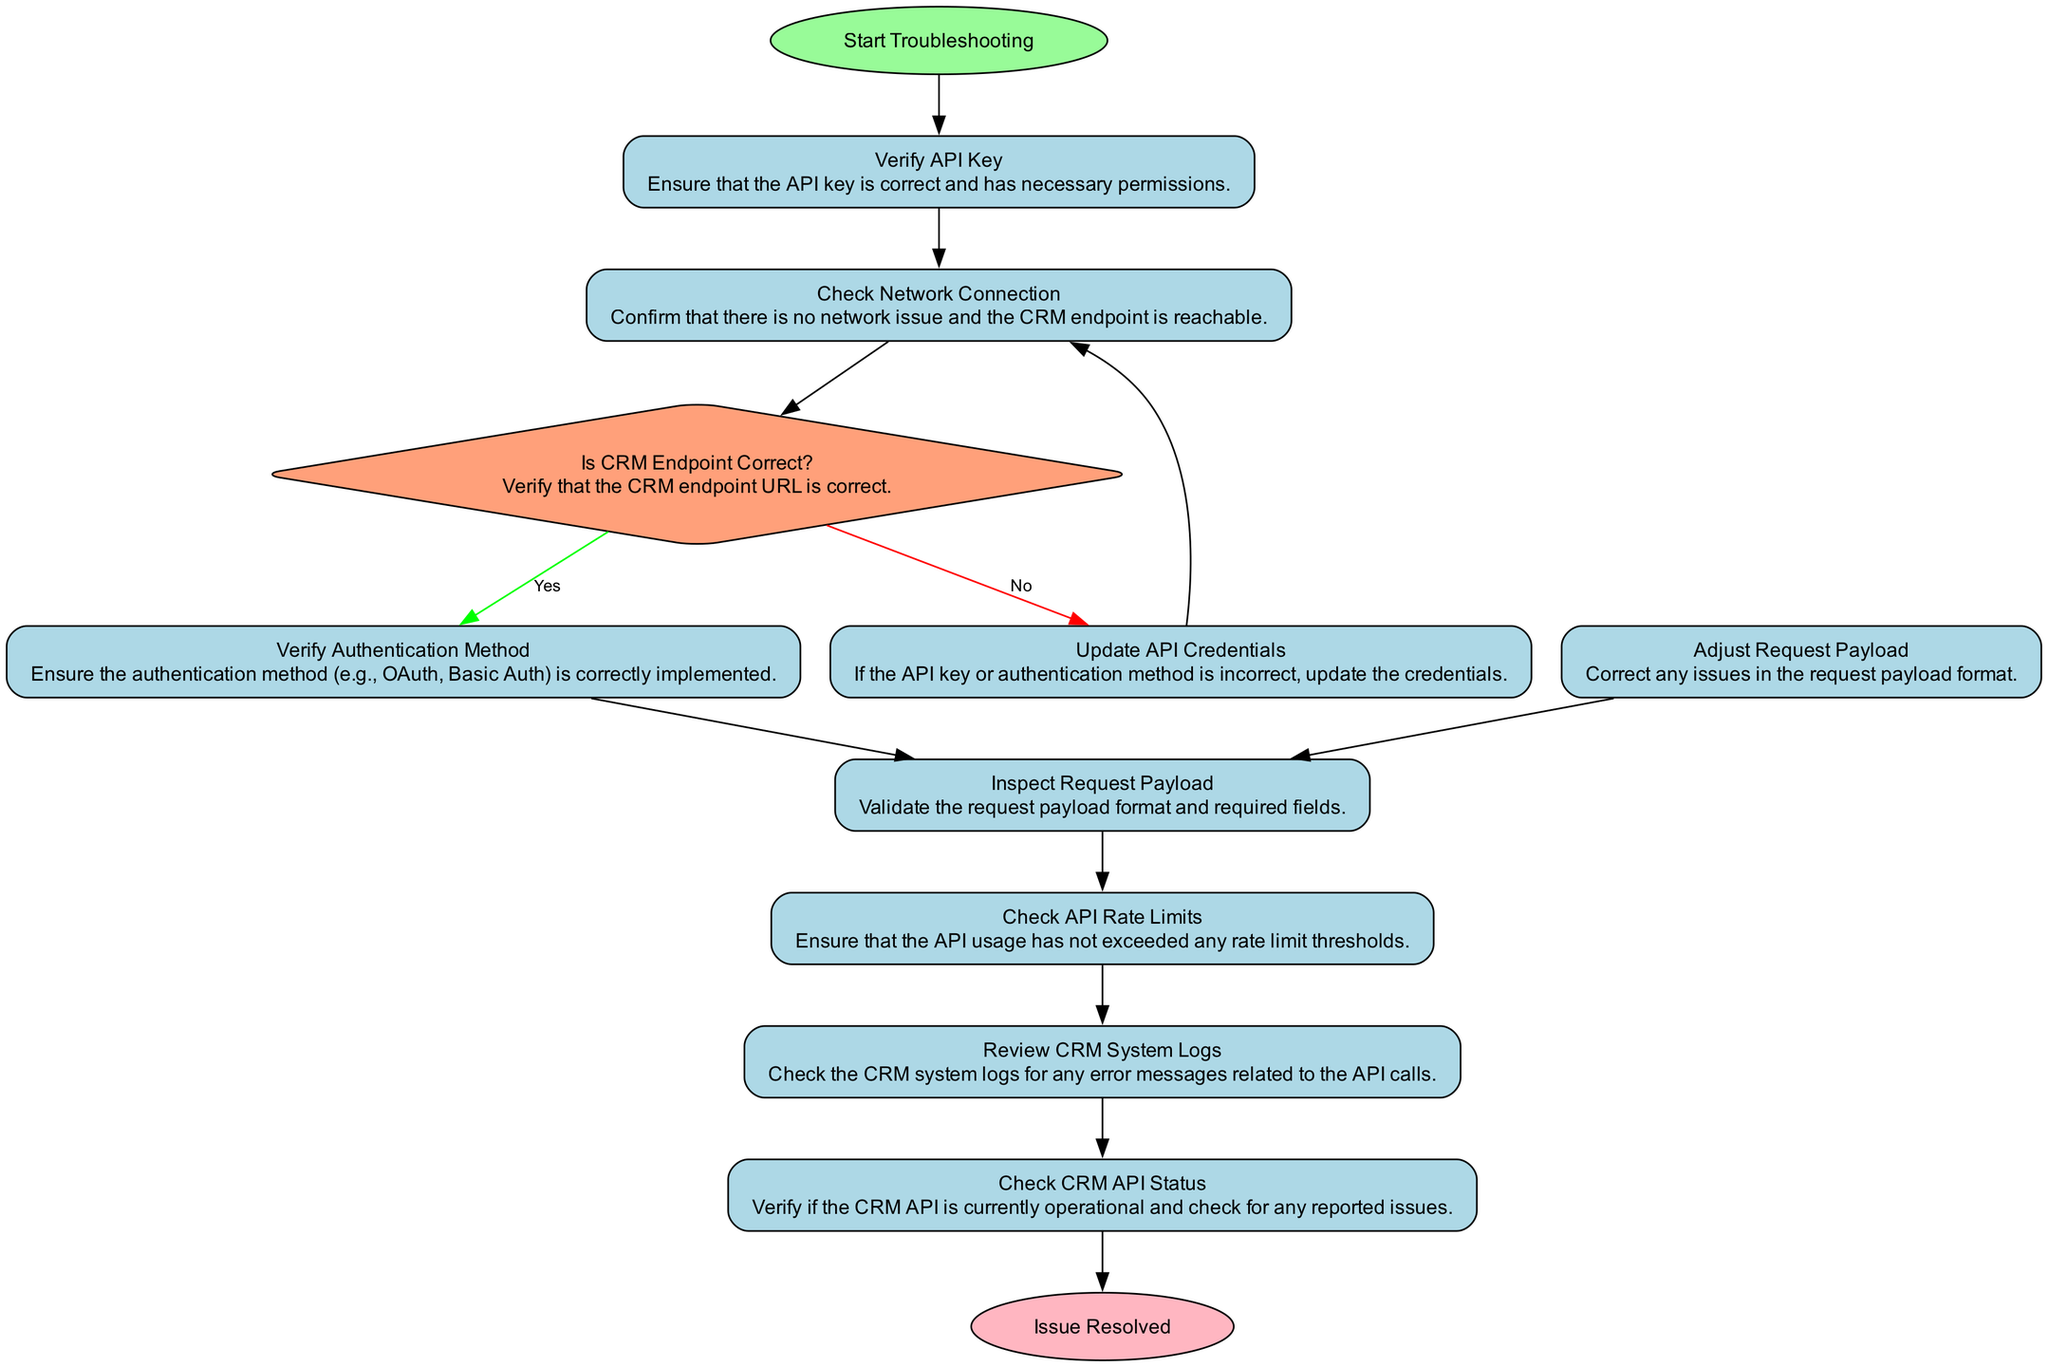What is the first step in the troubleshooting process? The first step is labeled as "Start Troubleshooting," which serves as the entry point to the flow chart.
Answer: Start Troubleshooting How many processes are present in the diagram? By counting the nodes with the type "process," I find that there are seven process nodes in the diagram (check_api_key, check_network, check_authentication, inspect_payload, check_rate_limit, review_logs, update_credentials).
Answer: Seven What happens if the CRM Endpoint is not correct? If the CRM endpoint is not correct, the flow indicates to "Update API Credentials," which means to correct the issues with the API key or authentication method.
Answer: Update API Credentials What node comes after "Inspect Request Payload"? Following "Inspect Request Payload," the next step in the diagram is "Check API Rate Limits," indicating the sequence of troubleshooting actions.
Answer: Check API Rate Limits How does one return to checking the network after updating credentials? The flow indicates that after "Update API Credentials," the process directs back to "Check Network Connection," looping back to verify the network status again.
Answer: Check Network Connection How many decision points are present in the diagram? There is one decision point in the diagram indicated by the "Is CRM Endpoint Correct?" node, which branches the flow based on a yes or no response.
Answer: One What is the final step after checking the CRM API status? The final step in the diagram is labeled "Issue Resolved," which signifies the conclusion of the troubleshooting process once the API status is confirmed to be operational.
Answer: Issue Resolved What indicates that the API key might be incorrect in the flow? If the verification of the API key fails, it leads to the step where credentials need to be updated, indicating that the API key or authentication method is likely incorrect.
Answer: Update API Credentials What is the last process you perform before checking the CRM API status? The last process before checking the CRM API status is "Review CRM System Logs," which gathers additional insights on any encountered issues.
Answer: Review CRM System Logs 